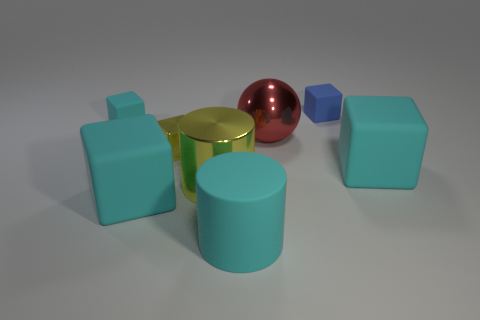Subtract all small matte blocks. How many blocks are left? 3 Subtract all yellow spheres. How many cyan blocks are left? 3 Add 2 big cyan rubber things. How many objects exist? 10 Subtract all cylinders. How many objects are left? 6 Subtract all yellow blocks. How many blocks are left? 4 Subtract 2 cylinders. How many cylinders are left? 0 Subtract 1 blue cubes. How many objects are left? 7 Subtract all blue cubes. Subtract all gray spheres. How many cubes are left? 4 Subtract all red metallic things. Subtract all cyan matte objects. How many objects are left? 3 Add 7 small blue rubber cubes. How many small blue rubber cubes are left? 8 